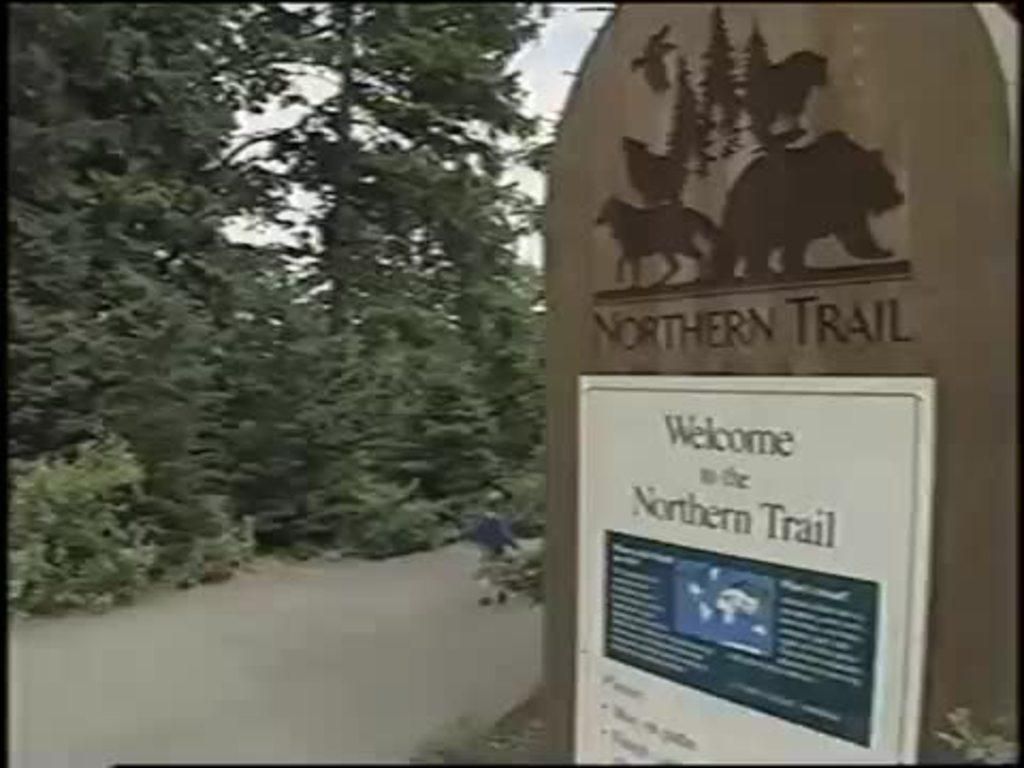<image>
Summarize the visual content of the image. A sign indicates the entrance of the Northern Trail and states the rules. 